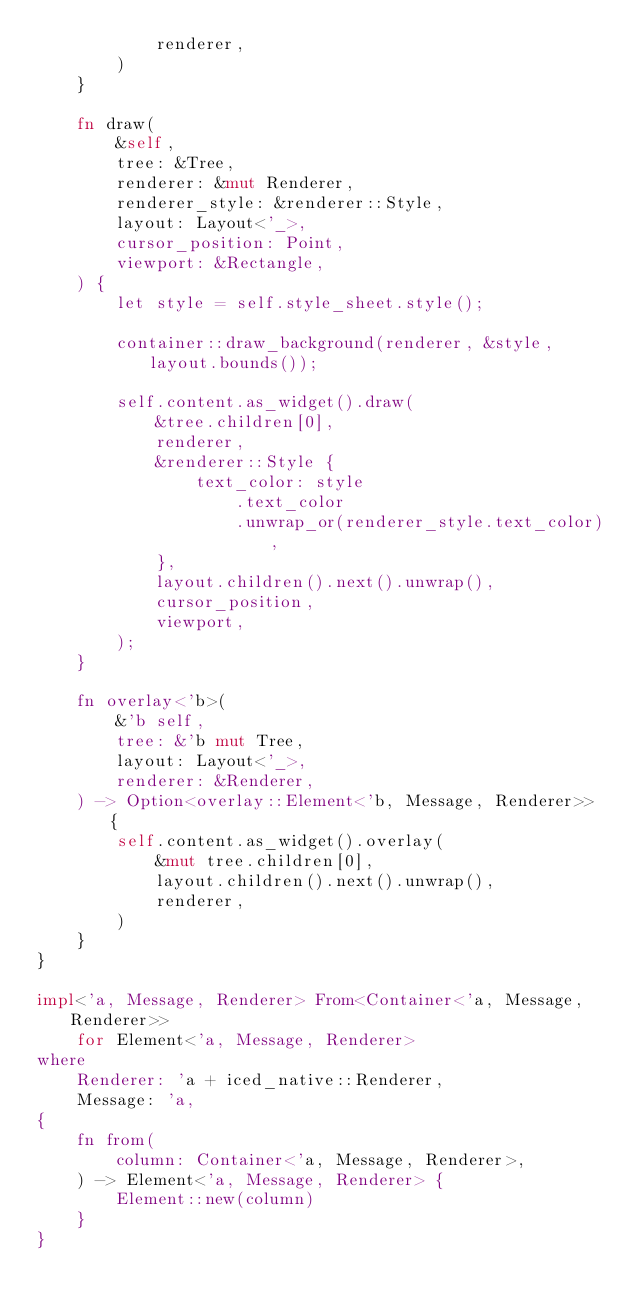<code> <loc_0><loc_0><loc_500><loc_500><_Rust_>            renderer,
        )
    }

    fn draw(
        &self,
        tree: &Tree,
        renderer: &mut Renderer,
        renderer_style: &renderer::Style,
        layout: Layout<'_>,
        cursor_position: Point,
        viewport: &Rectangle,
    ) {
        let style = self.style_sheet.style();

        container::draw_background(renderer, &style, layout.bounds());

        self.content.as_widget().draw(
            &tree.children[0],
            renderer,
            &renderer::Style {
                text_color: style
                    .text_color
                    .unwrap_or(renderer_style.text_color),
            },
            layout.children().next().unwrap(),
            cursor_position,
            viewport,
        );
    }

    fn overlay<'b>(
        &'b self,
        tree: &'b mut Tree,
        layout: Layout<'_>,
        renderer: &Renderer,
    ) -> Option<overlay::Element<'b, Message, Renderer>> {
        self.content.as_widget().overlay(
            &mut tree.children[0],
            layout.children().next().unwrap(),
            renderer,
        )
    }
}

impl<'a, Message, Renderer> From<Container<'a, Message, Renderer>>
    for Element<'a, Message, Renderer>
where
    Renderer: 'a + iced_native::Renderer,
    Message: 'a,
{
    fn from(
        column: Container<'a, Message, Renderer>,
    ) -> Element<'a, Message, Renderer> {
        Element::new(column)
    }
}
</code> 